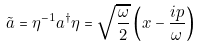<formula> <loc_0><loc_0><loc_500><loc_500>\tilde { a } = \eta ^ { - 1 } a ^ { \dagger } \eta = \sqrt { \frac { \omega } { 2 } } \left ( x - \frac { i p } { \omega } \right )</formula> 